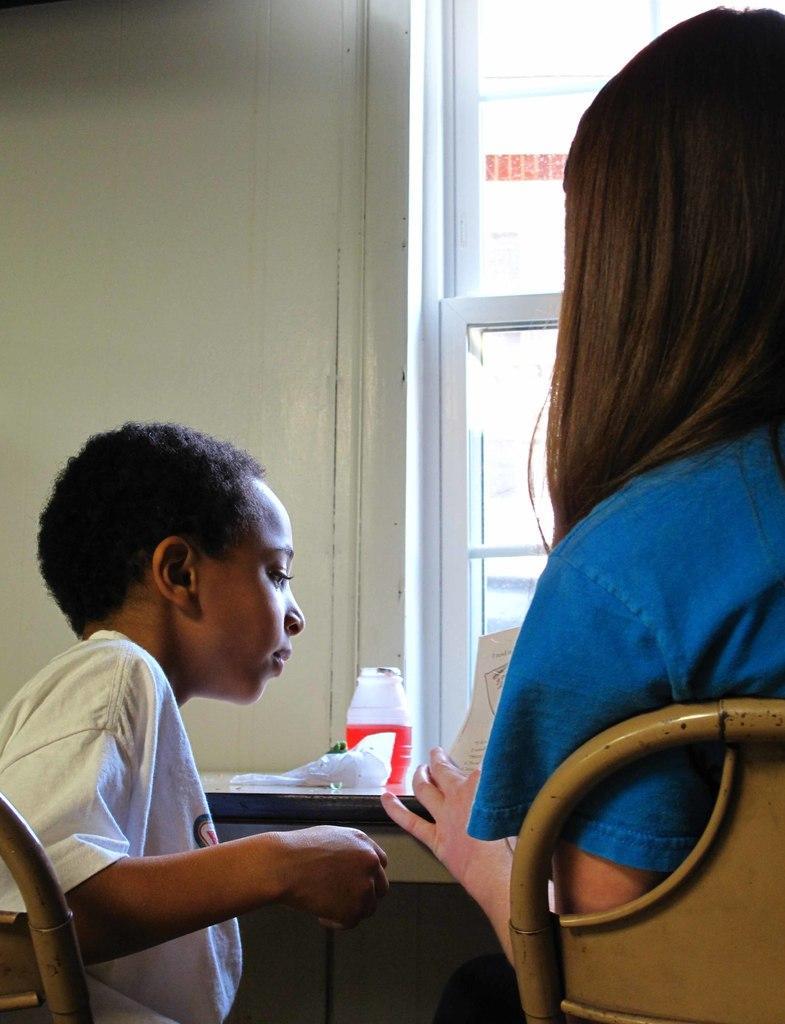How would you summarize this image in a sentence or two? The women wearing blue shirt is sitting in a chair in front of a table and there is a paper in her hand and there is a kid sitting beside her. 